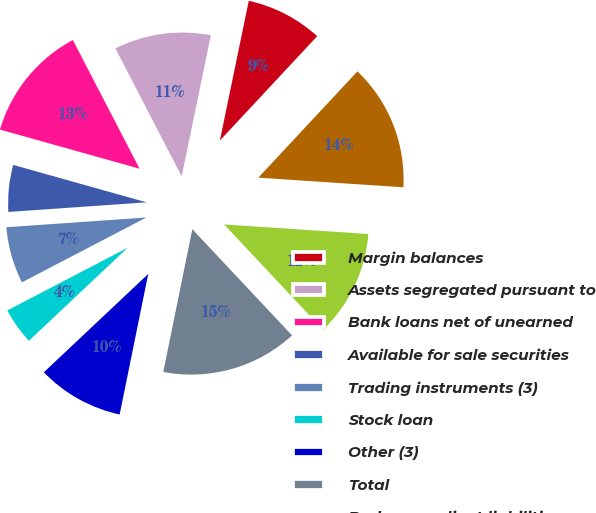Convert chart. <chart><loc_0><loc_0><loc_500><loc_500><pie_chart><fcel>Margin balances<fcel>Assets segregated pursuant to<fcel>Bank loans net of unearned<fcel>Available for sale securities<fcel>Trading instruments (3)<fcel>Stock loan<fcel>Other (3)<fcel>Total<fcel>Brokerage client liabilities<fcel>Bank deposits (2)<nl><fcel>8.7%<fcel>10.86%<fcel>13.03%<fcel>5.46%<fcel>6.54%<fcel>4.38%<fcel>9.78%<fcel>15.19%<fcel>11.95%<fcel>14.11%<nl></chart> 